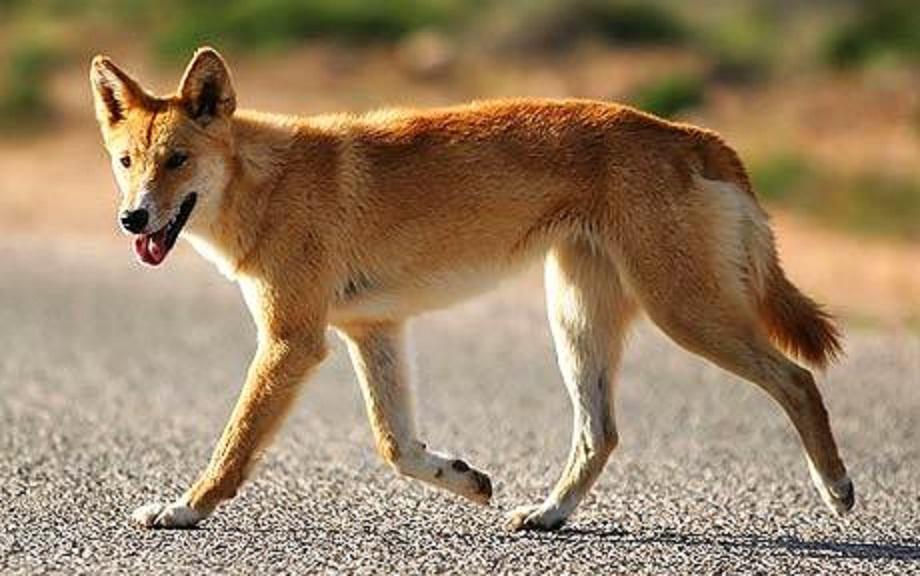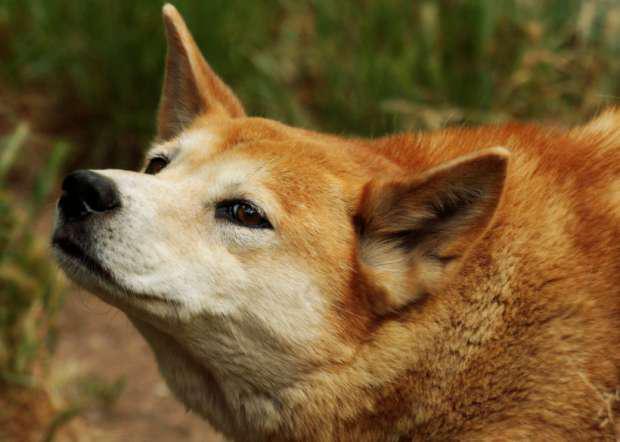The first image is the image on the left, the second image is the image on the right. For the images shown, is this caption "at lest one dog is showing its teeth" true? Answer yes or no. No. 